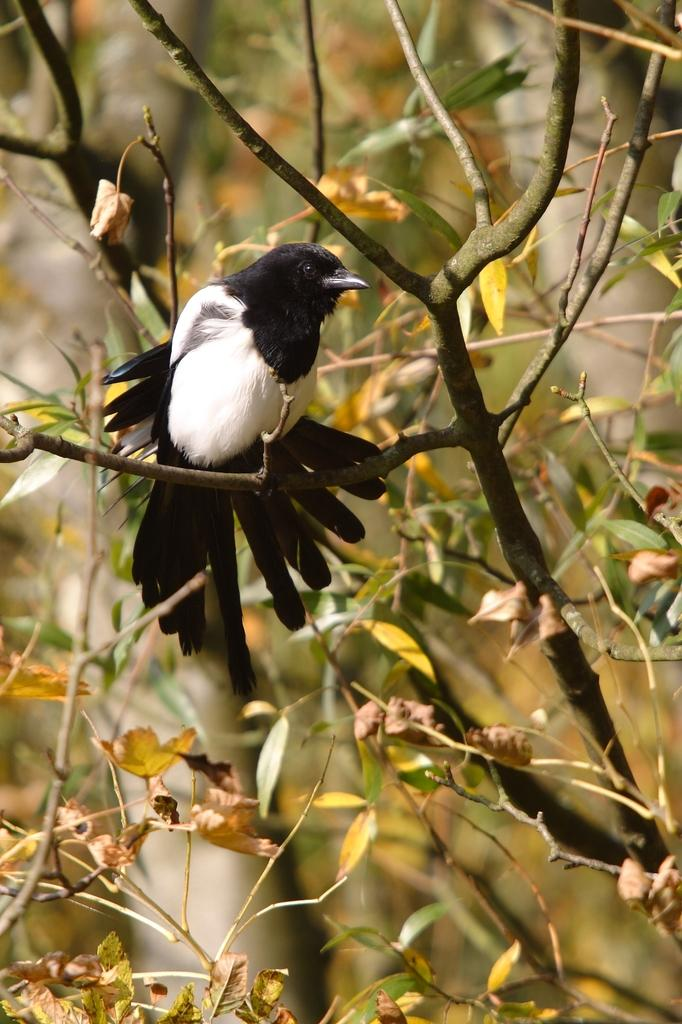What type of vegetation can be seen in the image? There are branches with leaves in the image. Are there any animals visible in the image? Yes, there is a bird in the image. Can you describe the background of the image? The background of the image is blurred. What type of bat is flying next to the bird in the image? There is no bat present in the image; only a bird and branches with leaves are visible. What type of trade is being conducted in the image? There is no trade being conducted in the image; it features a bird and branches with leaves. 